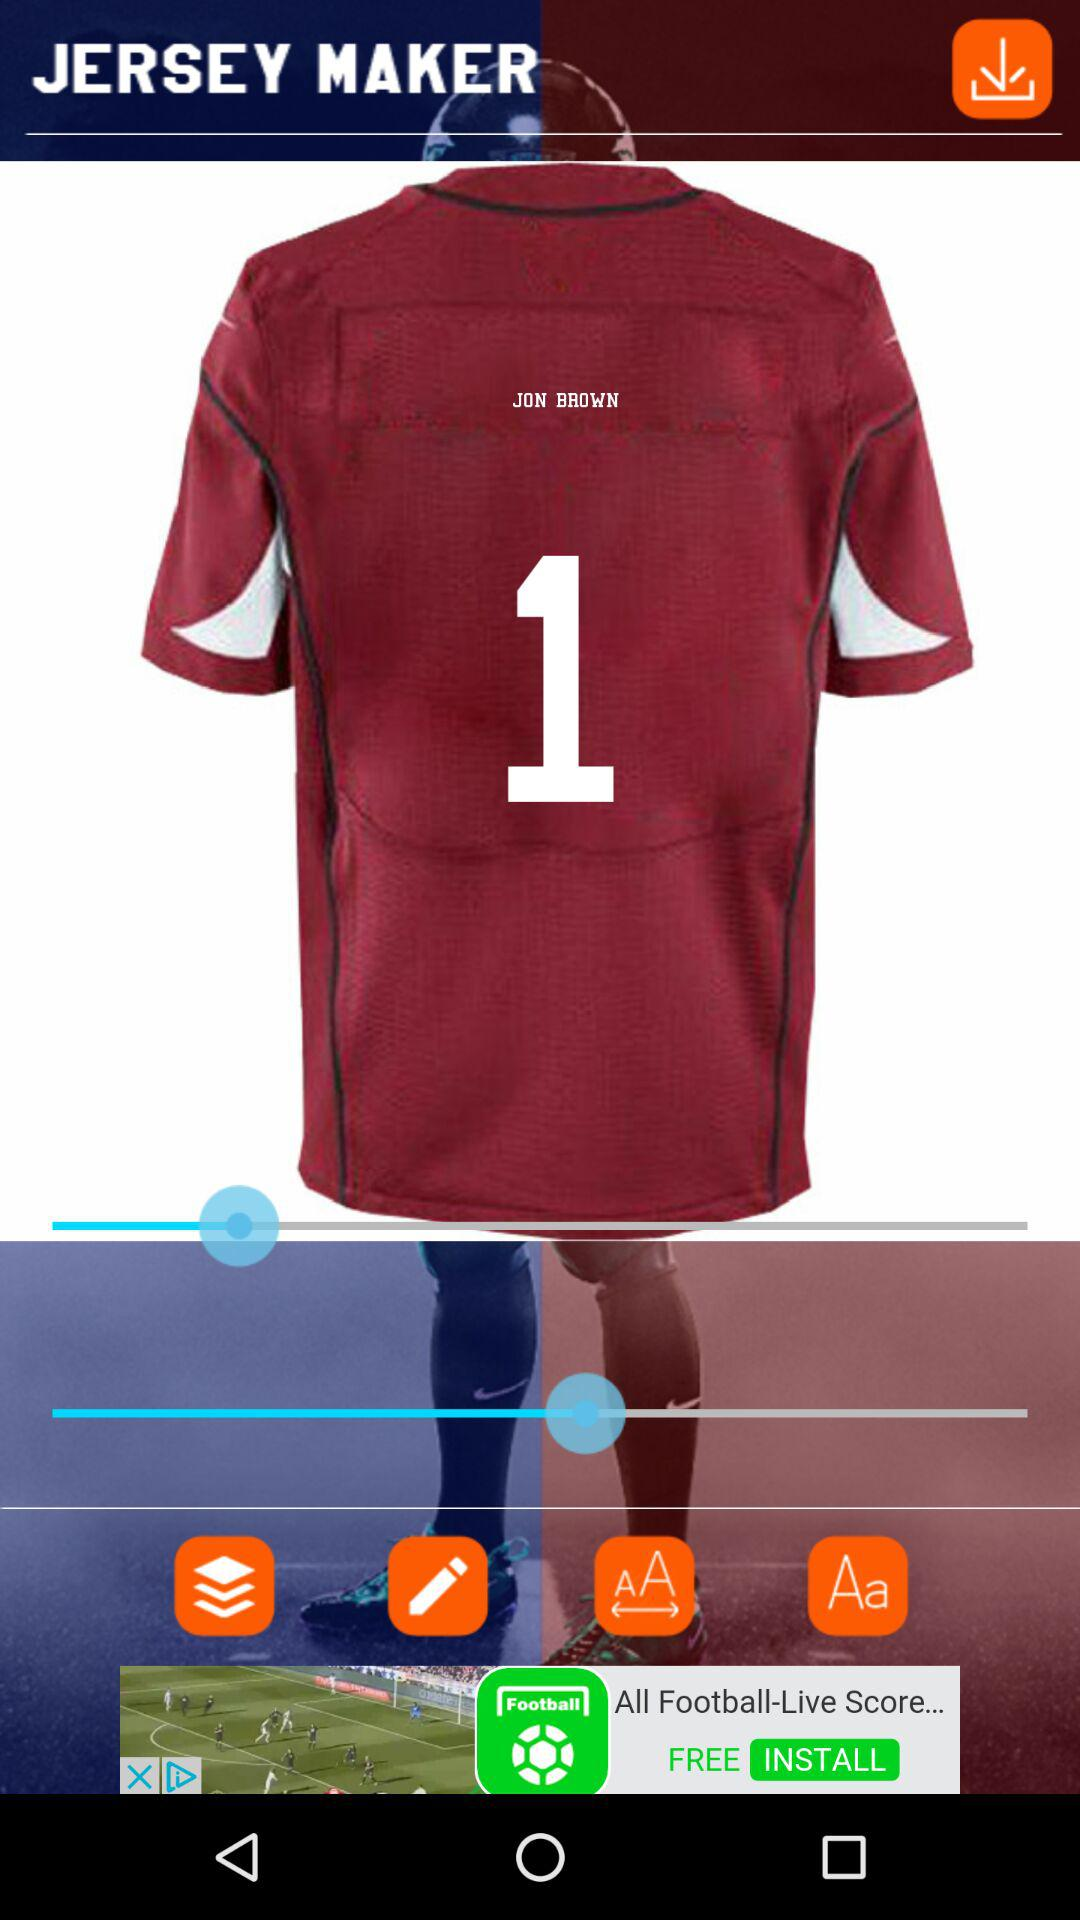What is the number written on the jersey? The number written on the jersey is 1. 